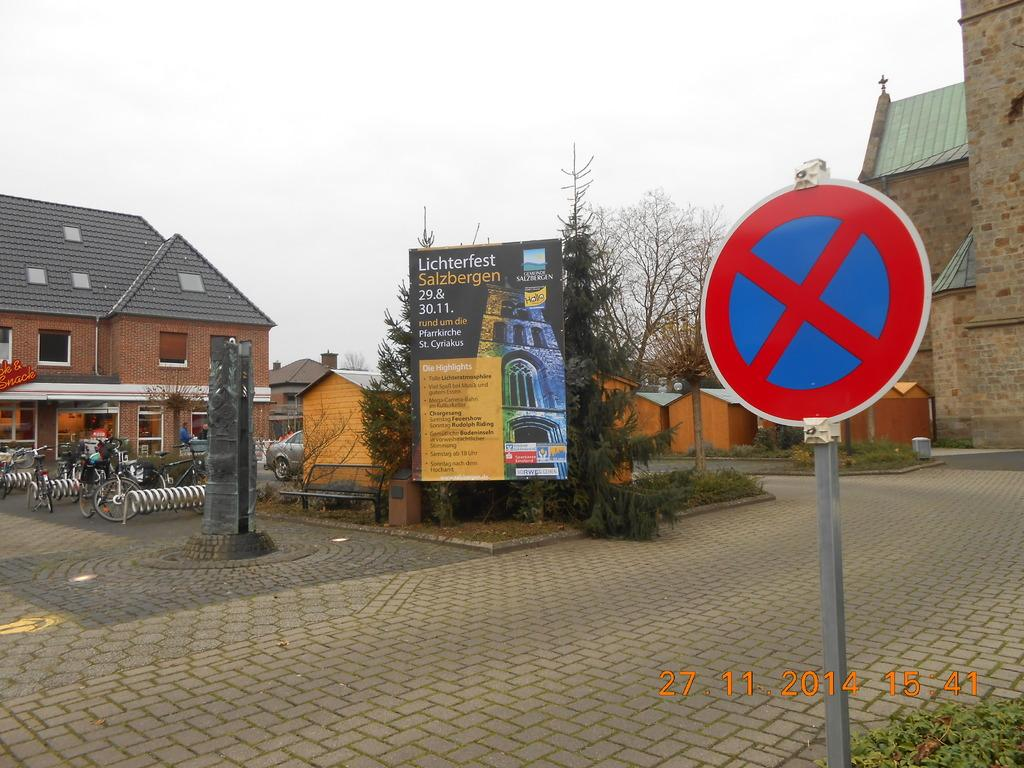<image>
Provide a brief description of the given image. A blue sign with a red cross on it is next to a banner that says Lichterfest Salzbergen. 